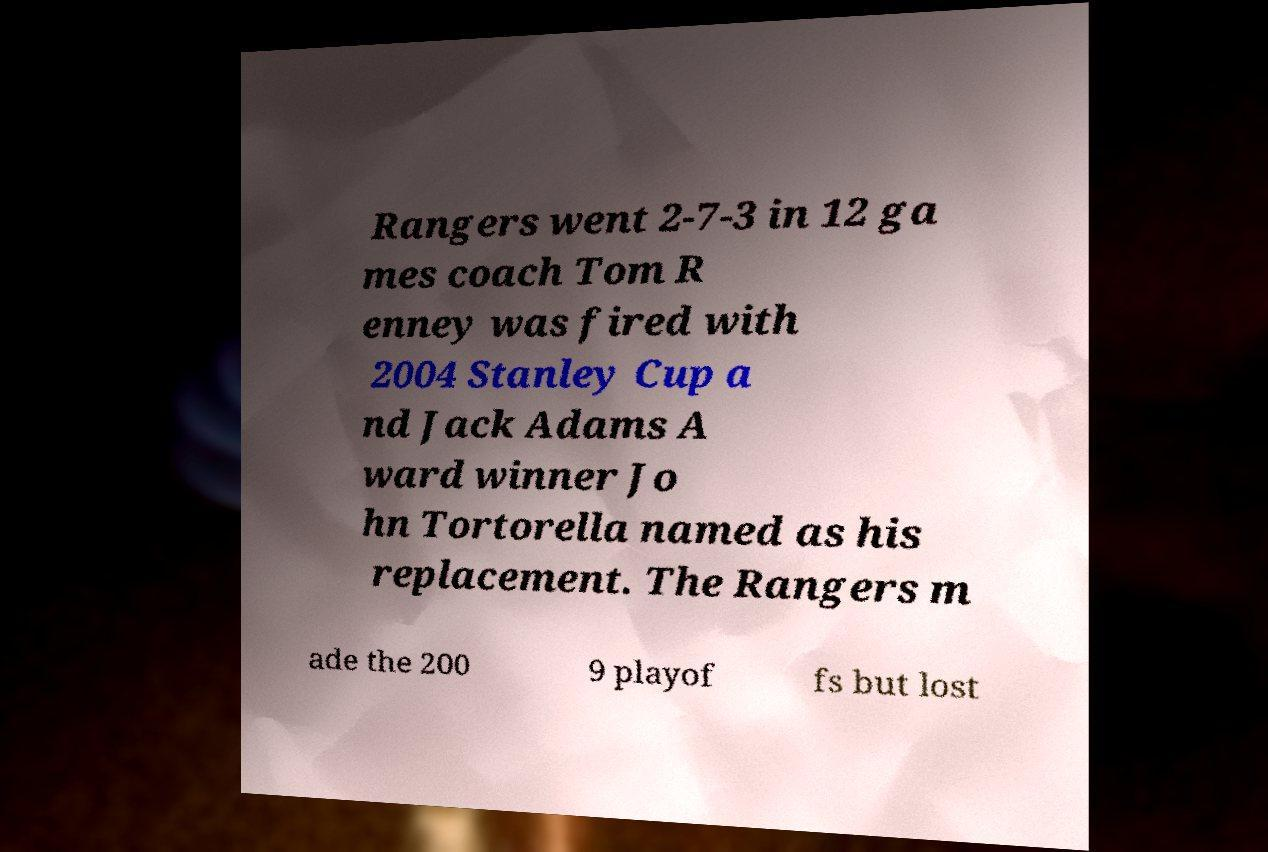Can you accurately transcribe the text from the provided image for me? Rangers went 2-7-3 in 12 ga mes coach Tom R enney was fired with 2004 Stanley Cup a nd Jack Adams A ward winner Jo hn Tortorella named as his replacement. The Rangers m ade the 200 9 playof fs but lost 